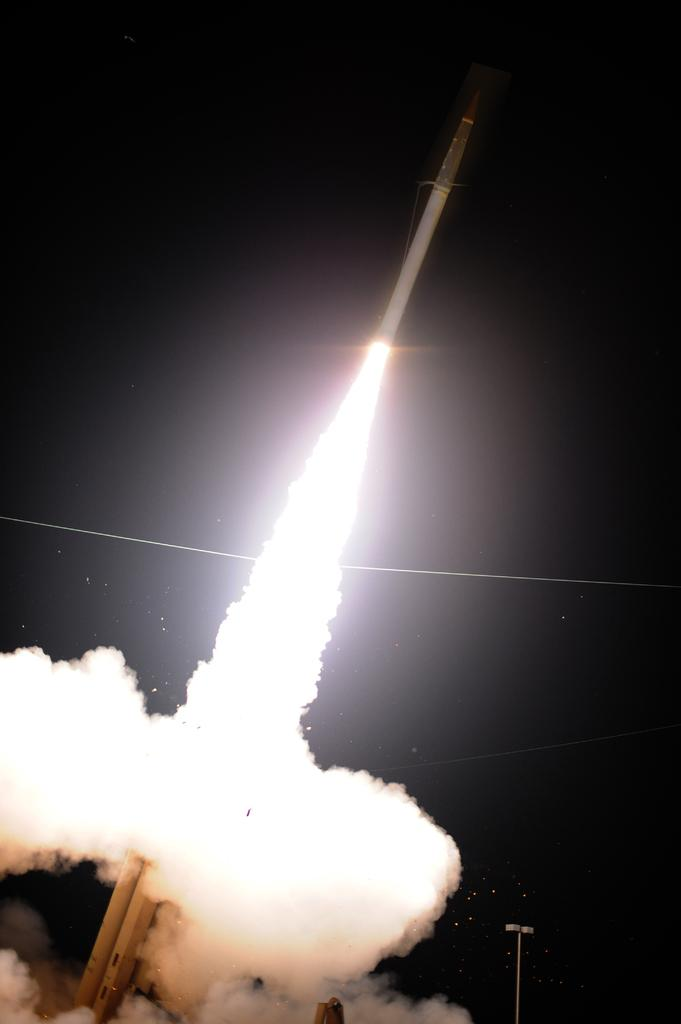What is the main subject of the image? The main subject of the image is a rocket. What is the rocket doing in the image? The rocket is flying in the air. What can be seen coming out of the rocket in the image? There is white color smoke coming out of the rocket in the image. What else is visible in the image besides the rocket? Light poles are visible in the image. What is the color of the sky in the background of the image? The sky in the background of the image is dark. Can you see a giraffe grazing near the seashore in the image? No, there is no giraffe or seashore present in the image. The image features a rocket flying in the air with white color smoke, light poles, and a dark sky in the background. 